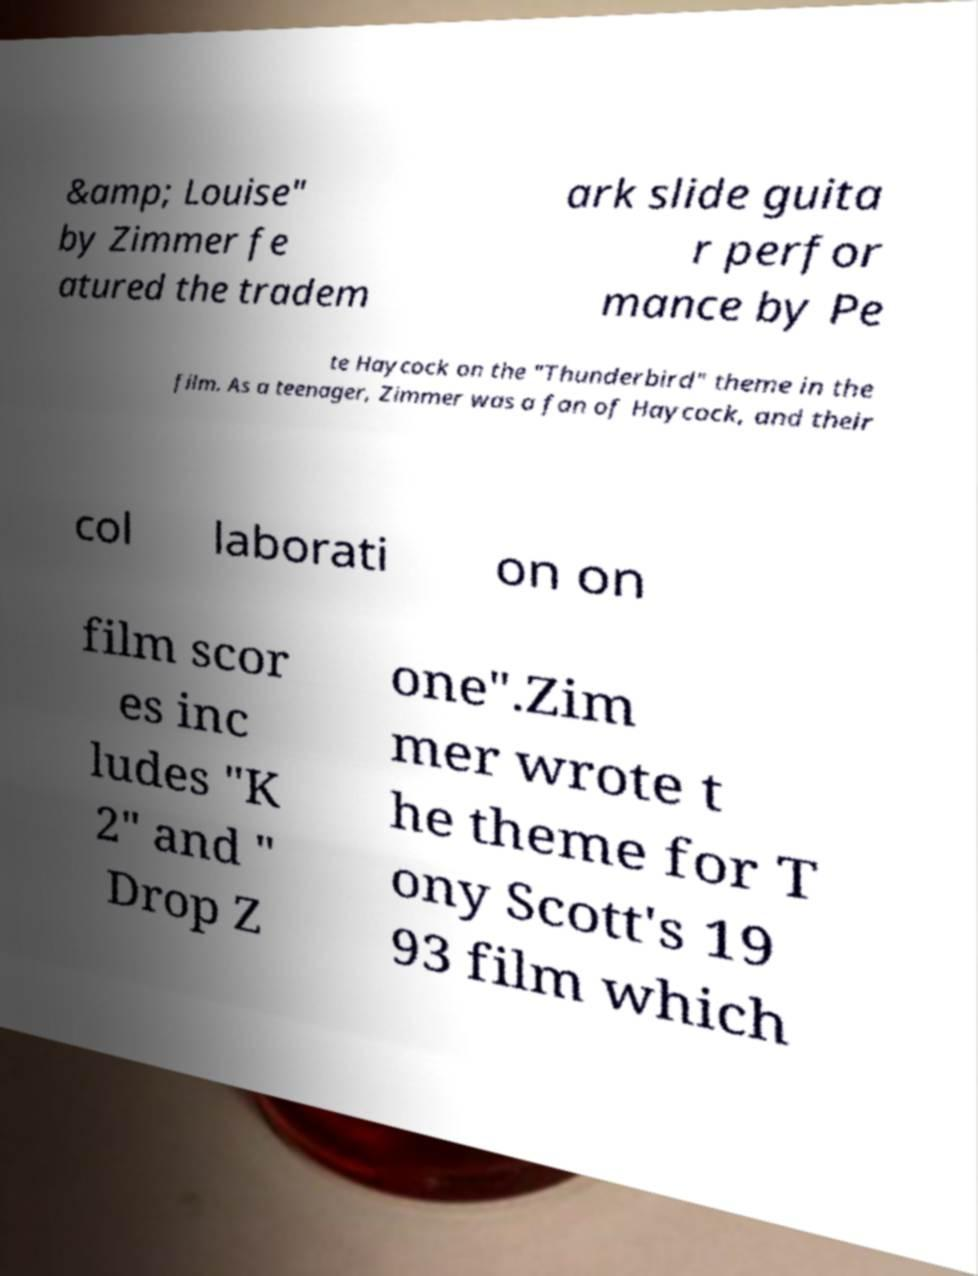Could you assist in decoding the text presented in this image and type it out clearly? &amp; Louise" by Zimmer fe atured the tradem ark slide guita r perfor mance by Pe te Haycock on the "Thunderbird" theme in the film. As a teenager, Zimmer was a fan of Haycock, and their col laborati on on film scor es inc ludes "K 2" and " Drop Z one".Zim mer wrote t he theme for T ony Scott's 19 93 film which 